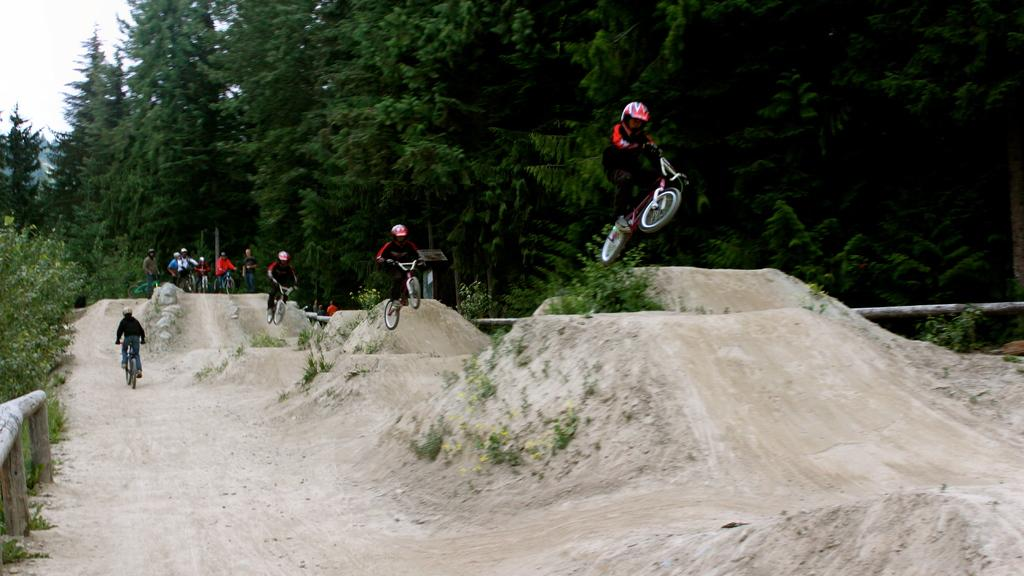What are the people in the image doing? The people in the image are riding bicycles. What type of vegetation can be seen in the image? There are trees and plants in the image. What is the condition of the sky in the image? The sky is cloudy in the image. What type of ornament is hanging from the bicycle in the image? There is no ornament hanging from the bicycle in the image. What material is the leather used for in the image? There is no leather present in the image. 